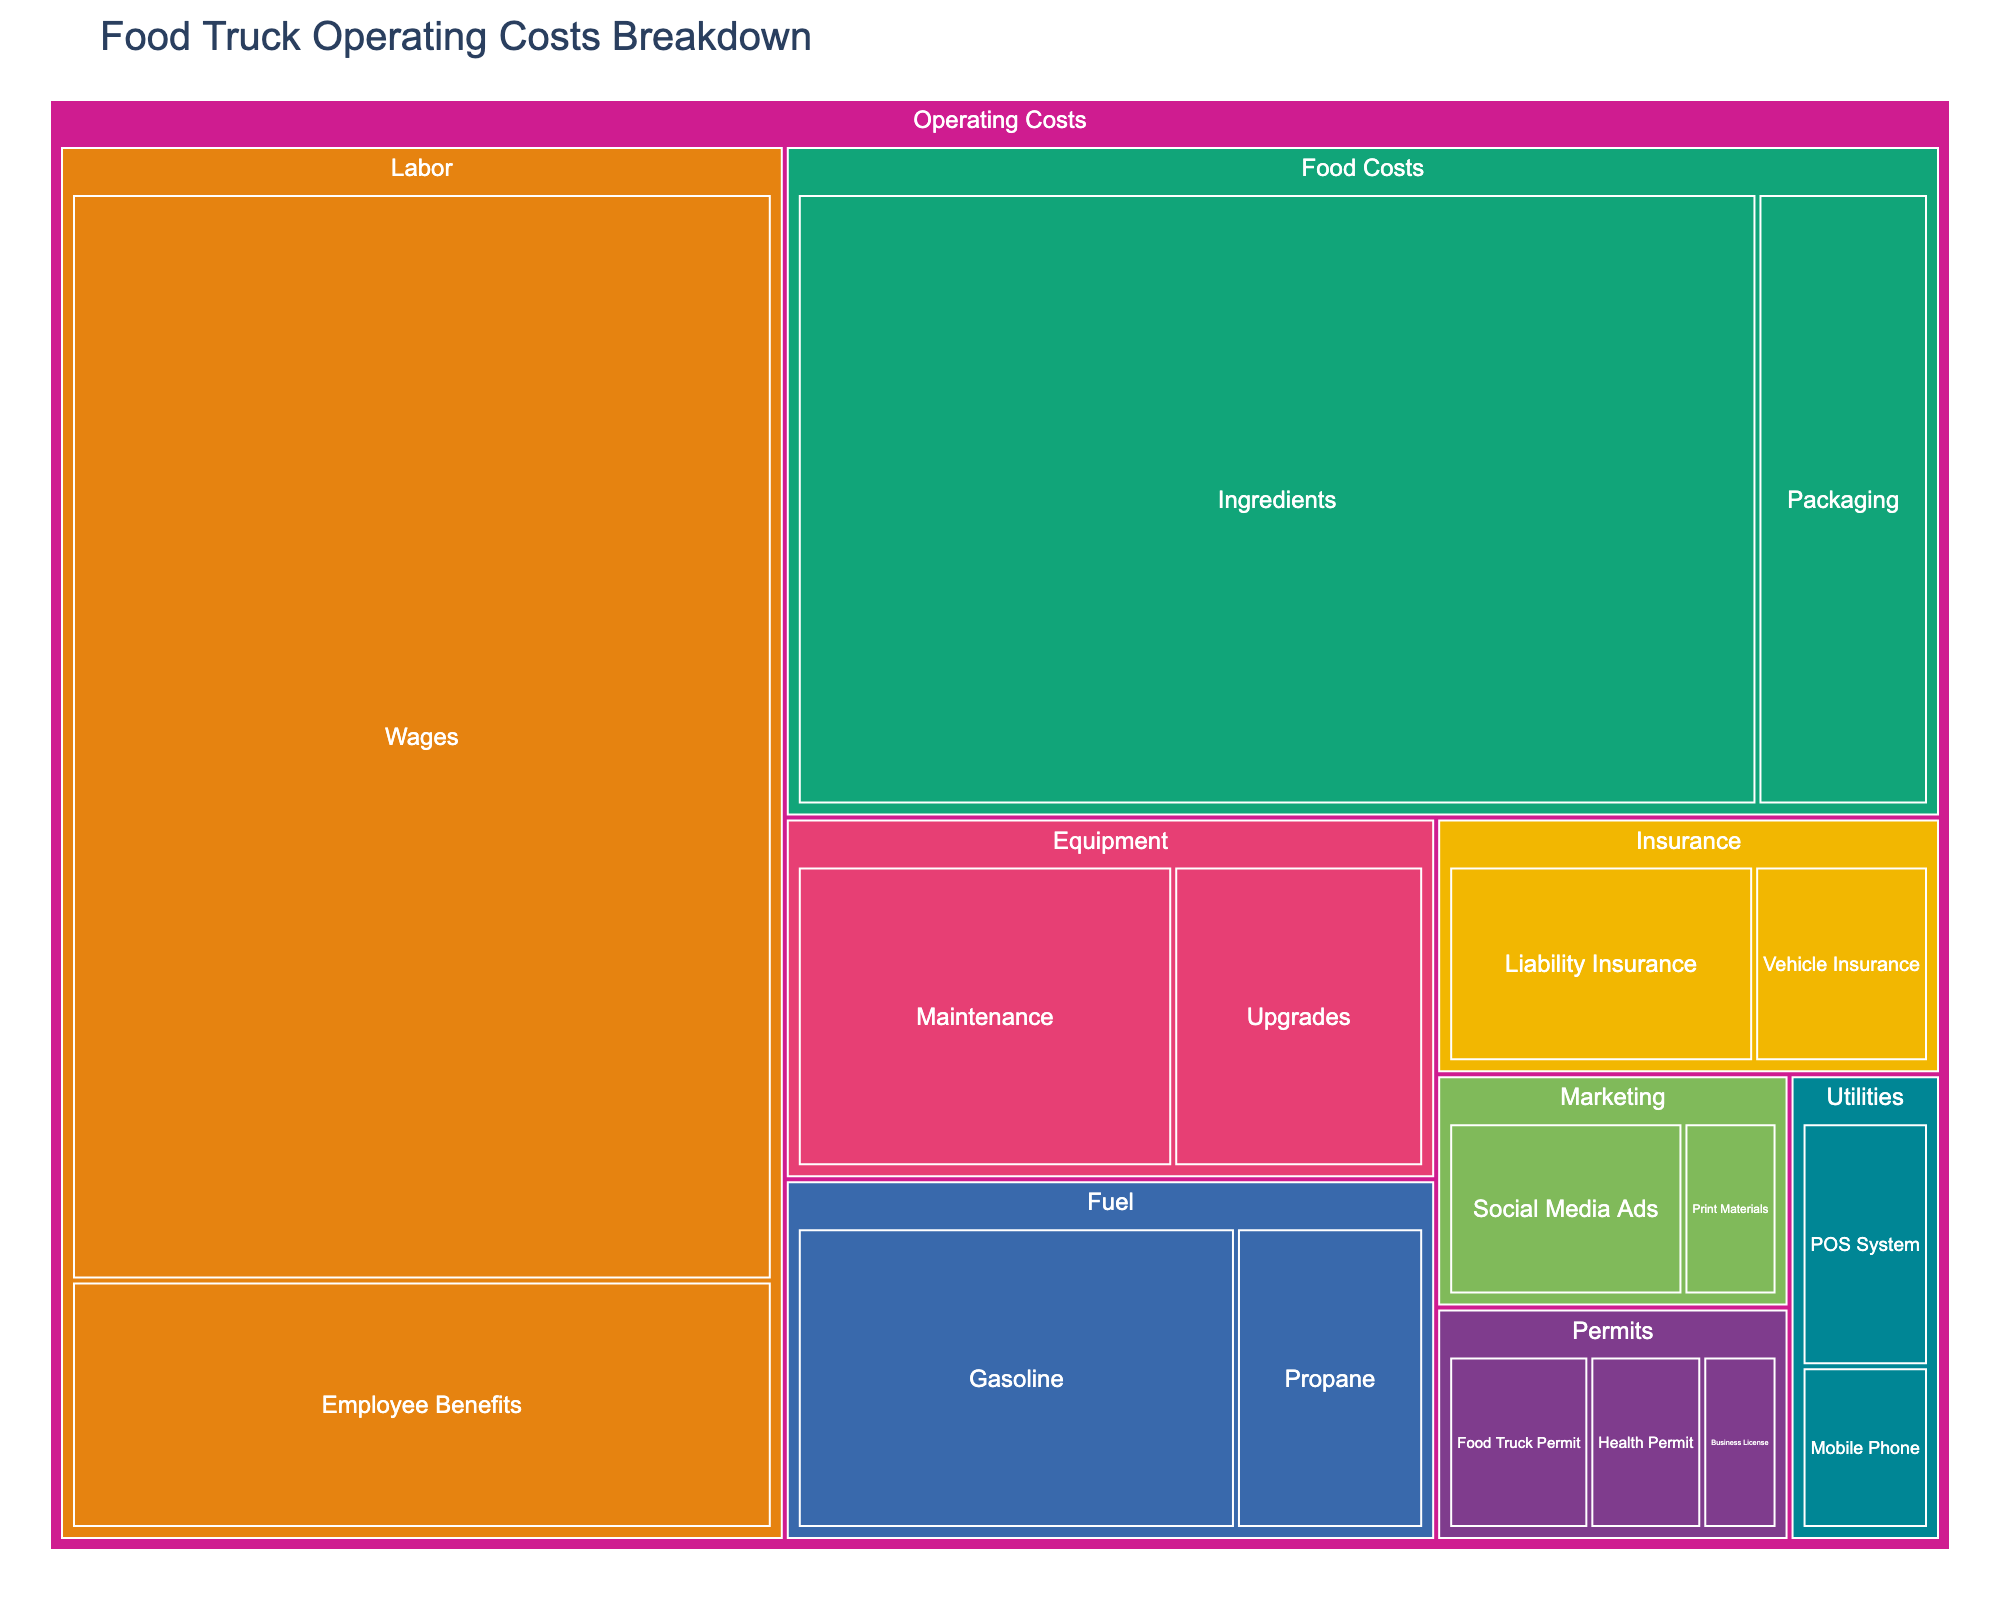What's the largest category in terms of operating costs? The treemap clearly shows the size of each category by its area. The largest area under the "Labor" category signifies that it is the biggest contributor to operating costs.
Answer: Labor Which subcategory under "Food Costs" has a higher value, "Ingredients" or "Packaging"? By comparing the size of the rectangles under "Food Costs," it's evident that "Ingredients" has a larger area than "Packaging."
Answer: Ingredients What is the total cost of permits? We need to sum the values of "Health Permit" ($1200), "Business License" ($800), and "Food Truck Permit" ($1500). The total cost is $1200 + $800 + $1500 = $3500.
Answer: $3500 Which category has the lowest associated cost? By identifying the smallest rectangle area in the treemap, we can see that "Utilities" has the smallest size, indicating it has the lowest cost.
Answer: Utilities How much is spent on fuel in total? To find the total cost for fuel, add the costs for "Gasoline" ($7000) and "Propane" ($3000). The total is $7000 + $3000 = $10000.
Answer: $10000 What is the value difference between "Liability Insurance" and "Vehicle Insurance"? The value for "Liability Insurance" is $3500, and for "Vehicle Insurance" it’s $2000. The difference is $3500 - $2000 = $1500.
Answer: $1500 Which marketing subcategory has a higher cost? By comparing the size of the rectangles under the "Marketing" category, "Social Media Ads" has a larger area than "Print Materials."
Answer: Social Media Ads How much more is spent on wages compared to the entire insurance category? The value for "Wages" is $35000. The total for "Insurance" (sum of $3500 for "Liability Insurance" and $2000 for "Vehicle Insurance") is $5500. The difference is $35000 - $5500 = $29500.
Answer: $29500 Which subcategory has the highest cost within "Labor"? Under the "Labor" category, the subcategory "Wages" has a larger area than "Employee Benefits," indicating a higher cost.
Answer: Wages 